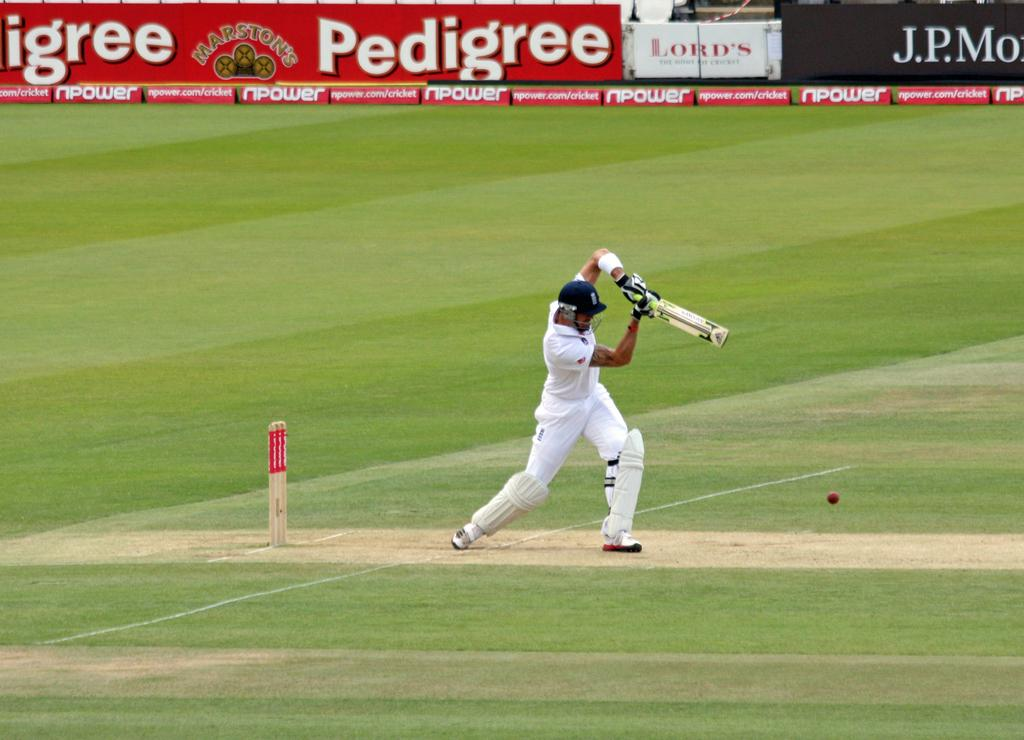Provide a one-sentence caption for the provided image. The cricket match advertisers included Pedigree, Lord's, npower, and J.P.Morgan. 